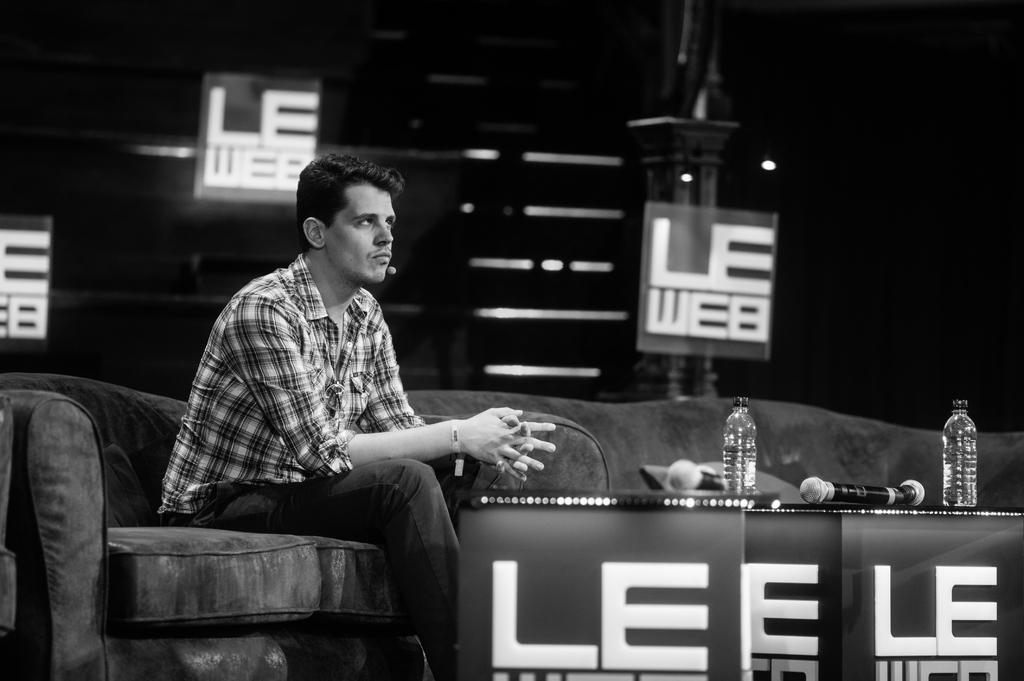Please provide a concise description of this image. This is a black and white image. On the left side there is a man sitting on a couch and looking at the right side. In front of this man there is a table on which two bottles and mike's are placed. In the background there are few boards and also I can see few objects in the dark. 